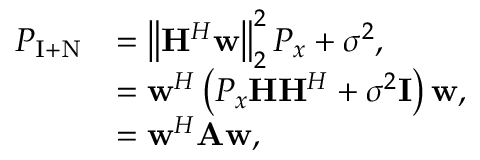Convert formula to latex. <formula><loc_0><loc_0><loc_500><loc_500>\begin{array} { r l } { P _ { I + N } } & { = \left \| H ^ { H } w \right \| _ { 2 } ^ { 2 } P _ { x } + \sigma ^ { 2 } , } \\ & { = w ^ { H } \left ( P _ { x } H H ^ { H } + \sigma ^ { 2 } I \right ) w , } \\ & { = w ^ { H } A w , } \end{array}</formula> 